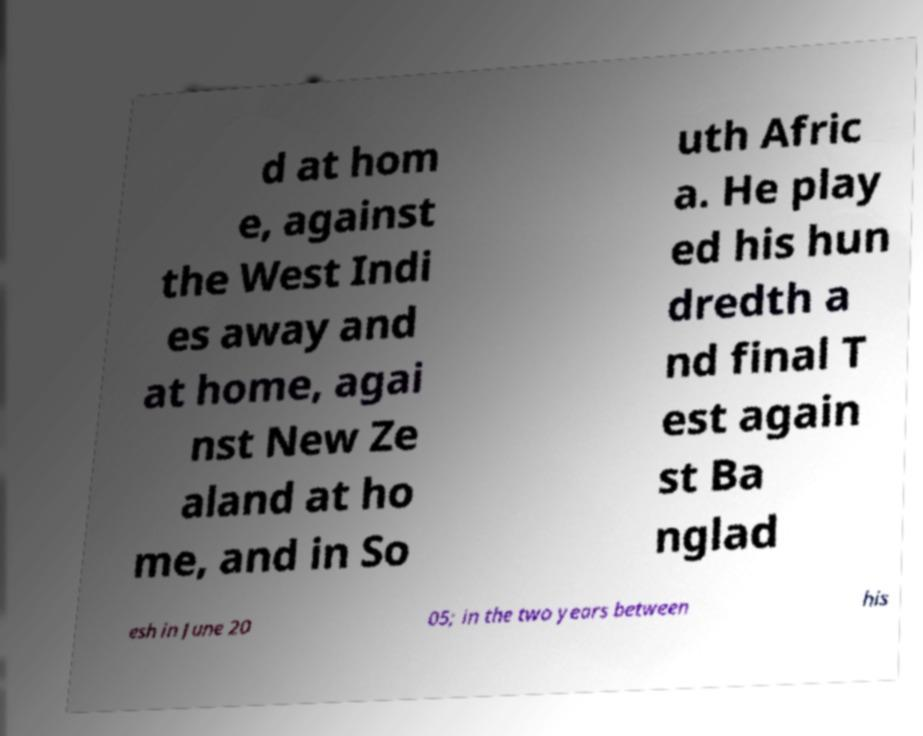Please read and relay the text visible in this image. What does it say? d at hom e, against the West Indi es away and at home, agai nst New Ze aland at ho me, and in So uth Afric a. He play ed his hun dredth a nd final T est again st Ba nglad esh in June 20 05; in the two years between his 